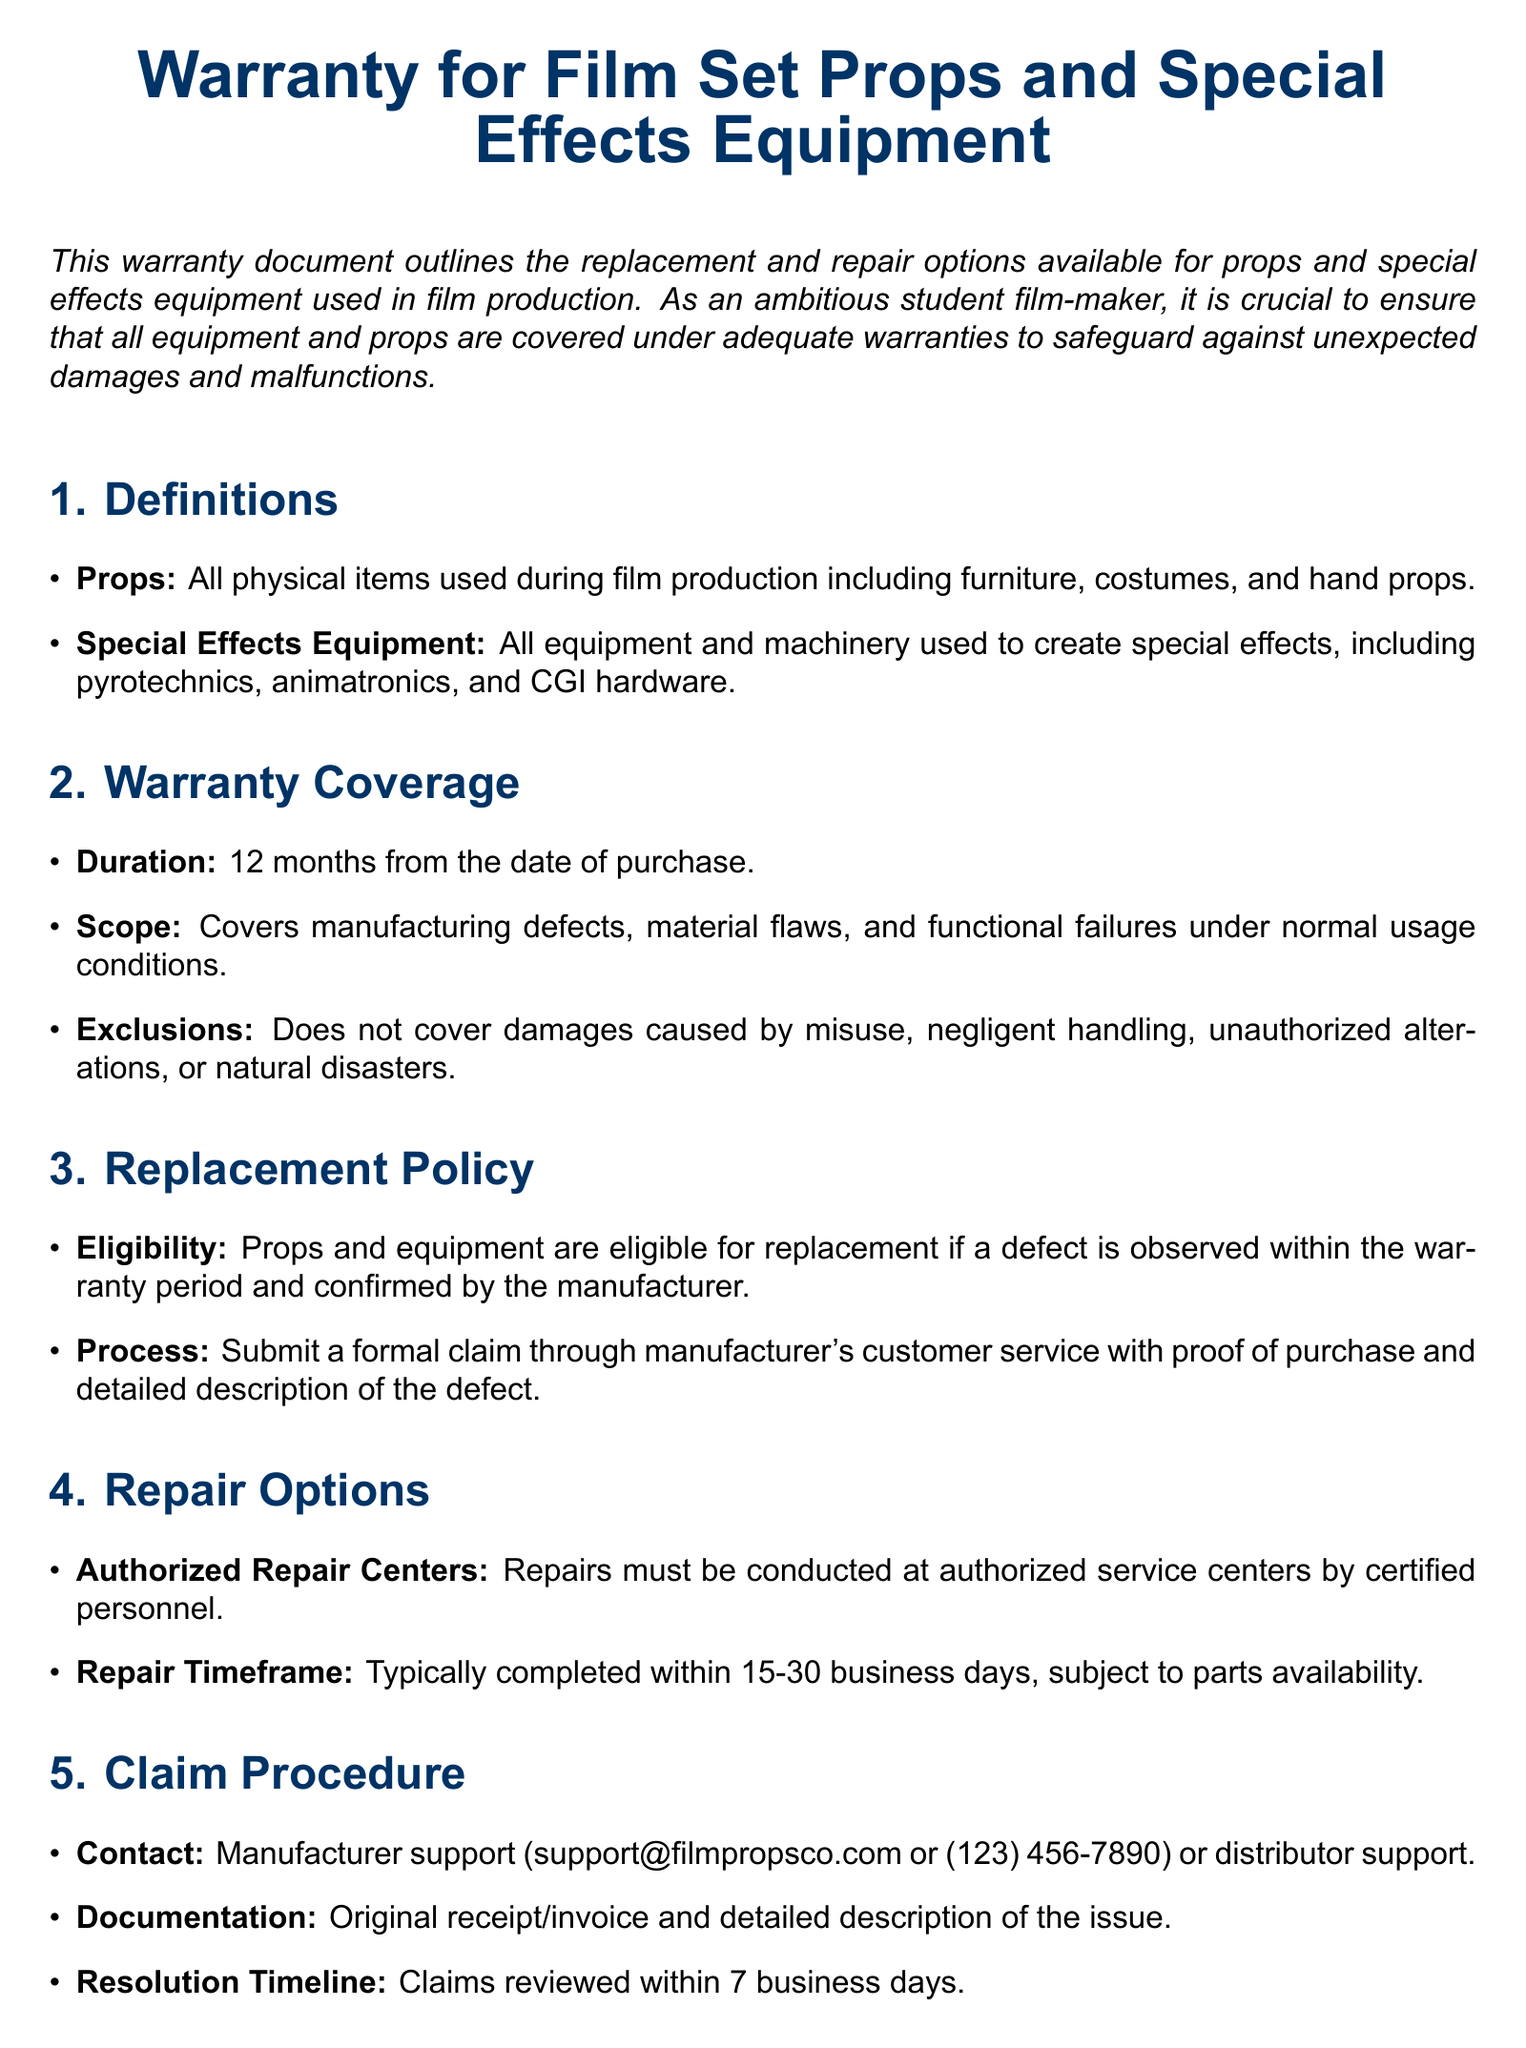What is the warranty duration? The warranty duration for the props and special effects equipment is explicitly stated in the document as 12 months from the date of purchase.
Answer: 12 months What items are considered props? The document defines props, including furniture, costumes, and hand props, which are physical items used during film production.
Answer: Furniture, costumes, hand props What must be submitted for a replacement claim? The document outlines that a formal claim must be submitted through manufacturer's customer service with proof of purchase and a detailed description of the defect.
Answer: Proof of purchase, description of defect What is the typical repair timeframe? The document mentions that repairs are typically completed within 15-30 business days, subject to parts availability.
Answer: 15-30 business days Who should be contacted for support? The warranty document states that the manufacturer support is available via email or phone for addressing warranty claims.
Answer: support@filmpropsco.com or (123) 456-7890 What damages are excluded from coverage? The document lists exclusions such as damages caused by misuse, negligent handling, unauthorized alterations, or natural disasters.
Answer: Misuse, negligent handling, unauthorized alterations, natural disasters What is the liability limit of the manufacturer? According to the document, the manufacturer's liability is limited to repair or replacement cost for the equipment.
Answer: Repair or replacement cost Where must repairs be conducted? The warranty specifies that repairs must be conducted at authorized service centers by certified personnel.
Answer: Authorized service centers 